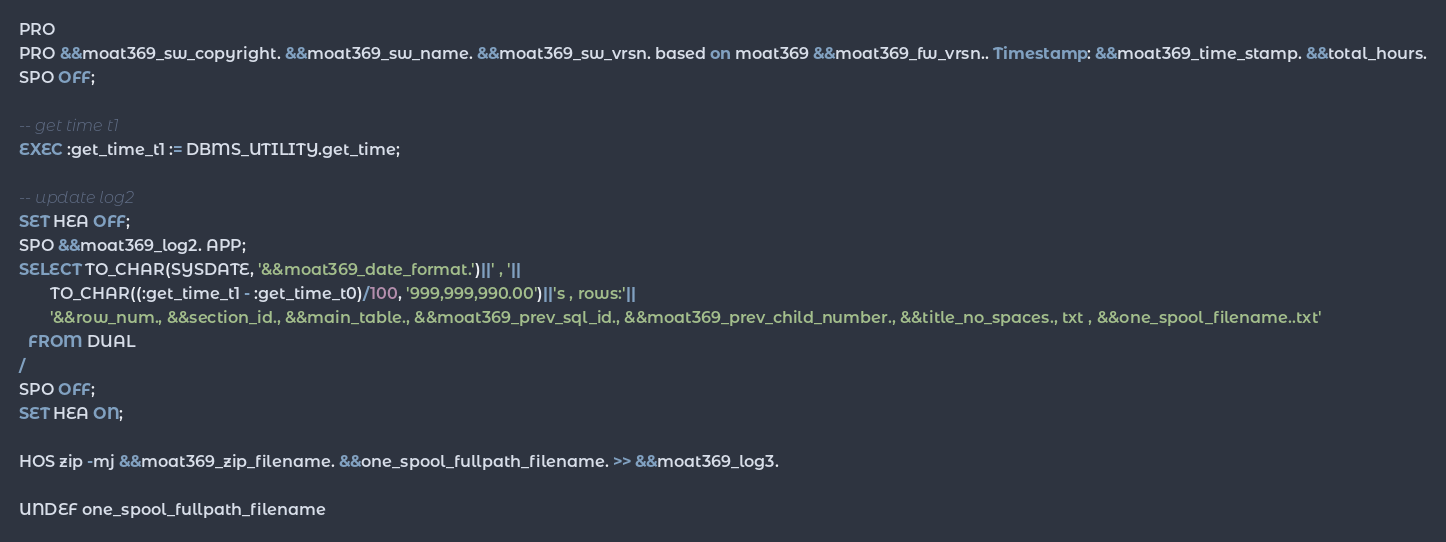Convert code to text. <code><loc_0><loc_0><loc_500><loc_500><_SQL_>PRO 
PRO &&moat369_sw_copyright. &&moat369_sw_name. &&moat369_sw_vrsn. based on moat369 &&moat369_fw_vrsn.. Timestamp: &&moat369_time_stamp. &&total_hours.
SPO OFF;

-- get time t1
EXEC :get_time_t1 := DBMS_UTILITY.get_time;

-- update log2
SET HEA OFF;
SPO &&moat369_log2. APP;
SELECT TO_CHAR(SYSDATE, '&&moat369_date_format.')||' , '||
       TO_CHAR((:get_time_t1 - :get_time_t0)/100, '999,999,990.00')||'s , rows:'||
       '&&row_num., &&section_id., &&main_table., &&moat369_prev_sql_id., &&moat369_prev_child_number., &&title_no_spaces., txt , &&one_spool_filename..txt'
  FROM DUAL
/
SPO OFF;
SET HEA ON;

HOS zip -mj &&moat369_zip_filename. &&one_spool_fullpath_filename. >> &&moat369_log3.

UNDEF one_spool_fullpath_filename</code> 